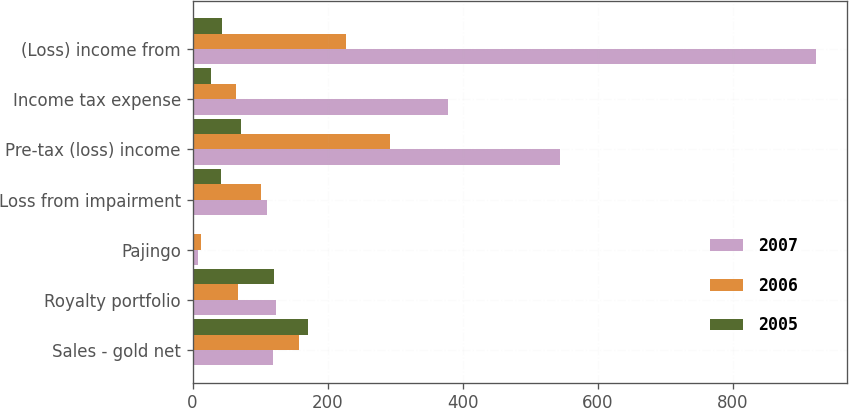Convert chart. <chart><loc_0><loc_0><loc_500><loc_500><stacked_bar_chart><ecel><fcel>Sales - gold net<fcel>Royalty portfolio<fcel>Pajingo<fcel>Loss from impairment<fcel>Pre-tax (loss) income<fcel>Income tax expense<fcel>(Loss) income from<nl><fcel>2007<fcel>119<fcel>123<fcel>8<fcel>110<fcel>544<fcel>379<fcel>923<nl><fcel>2006<fcel>157<fcel>67<fcel>12<fcel>101<fcel>293<fcel>65<fcel>228<nl><fcel>2005<fcel>171<fcel>121<fcel>1<fcel>42<fcel>72<fcel>28<fcel>44<nl></chart> 